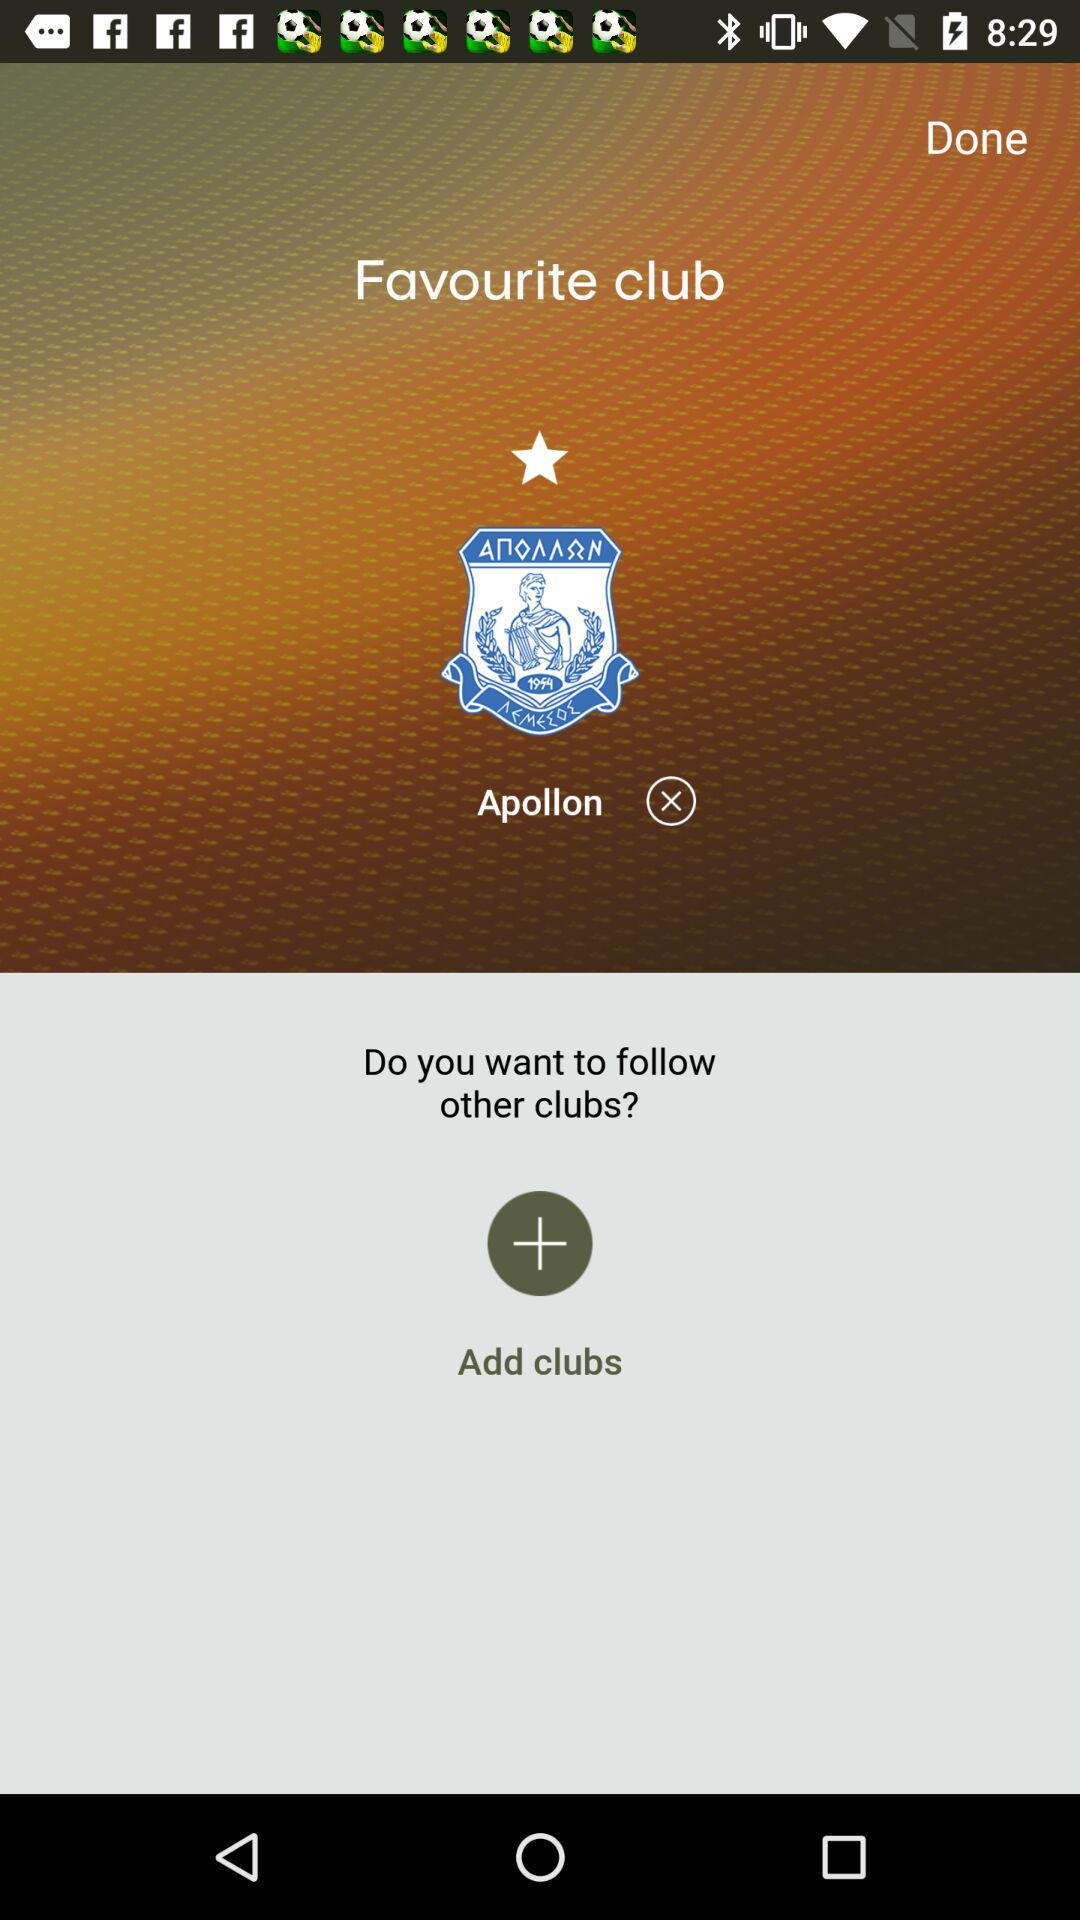What is the favourite club? The favourite club is "Apollon". 